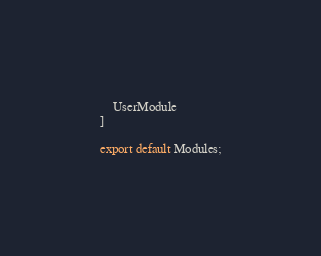<code> <loc_0><loc_0><loc_500><loc_500><_TypeScript_>    UserModule
]

export default Modules;</code> 